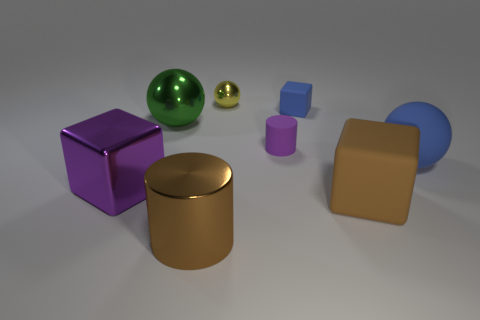Add 2 cyan rubber objects. How many objects exist? 10 Subtract all cylinders. How many objects are left? 6 Add 5 small green balls. How many small green balls exist? 5 Subtract 0 yellow cylinders. How many objects are left? 8 Subtract all tiny metal balls. Subtract all blue objects. How many objects are left? 5 Add 2 balls. How many balls are left? 5 